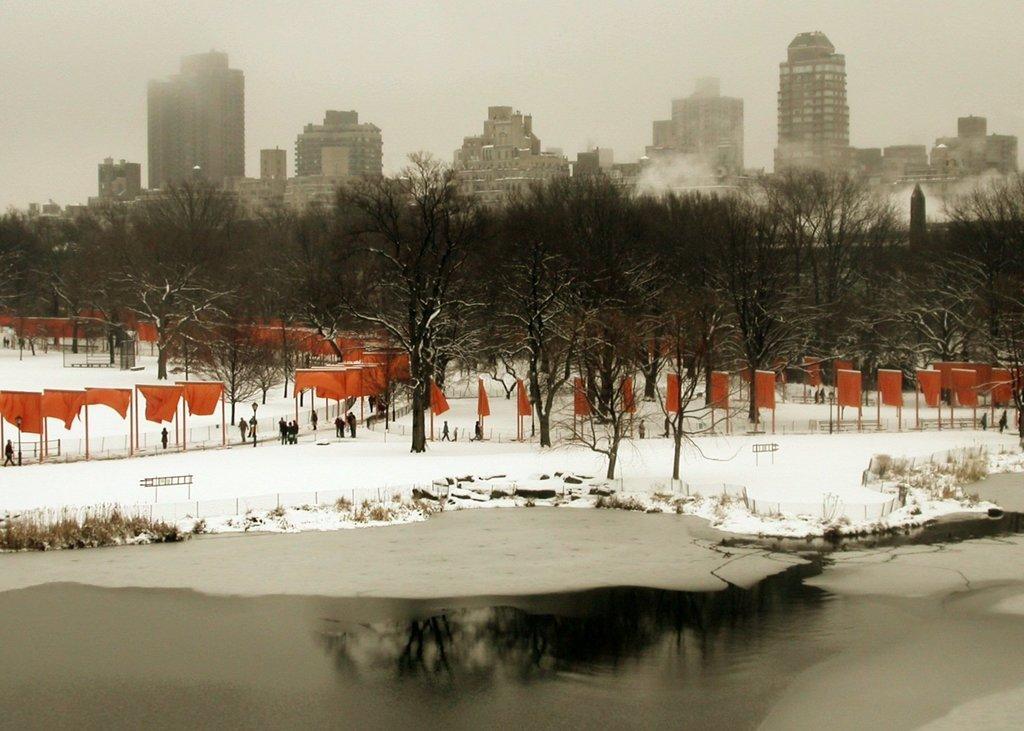Could you give a brief overview of what you see in this image? An outdoor picture. Far there are number of bare trees. Land is covered with snow. Flags are line by line. Front there is a freshwater river. Far there are number of buildings. Persons are standing. 